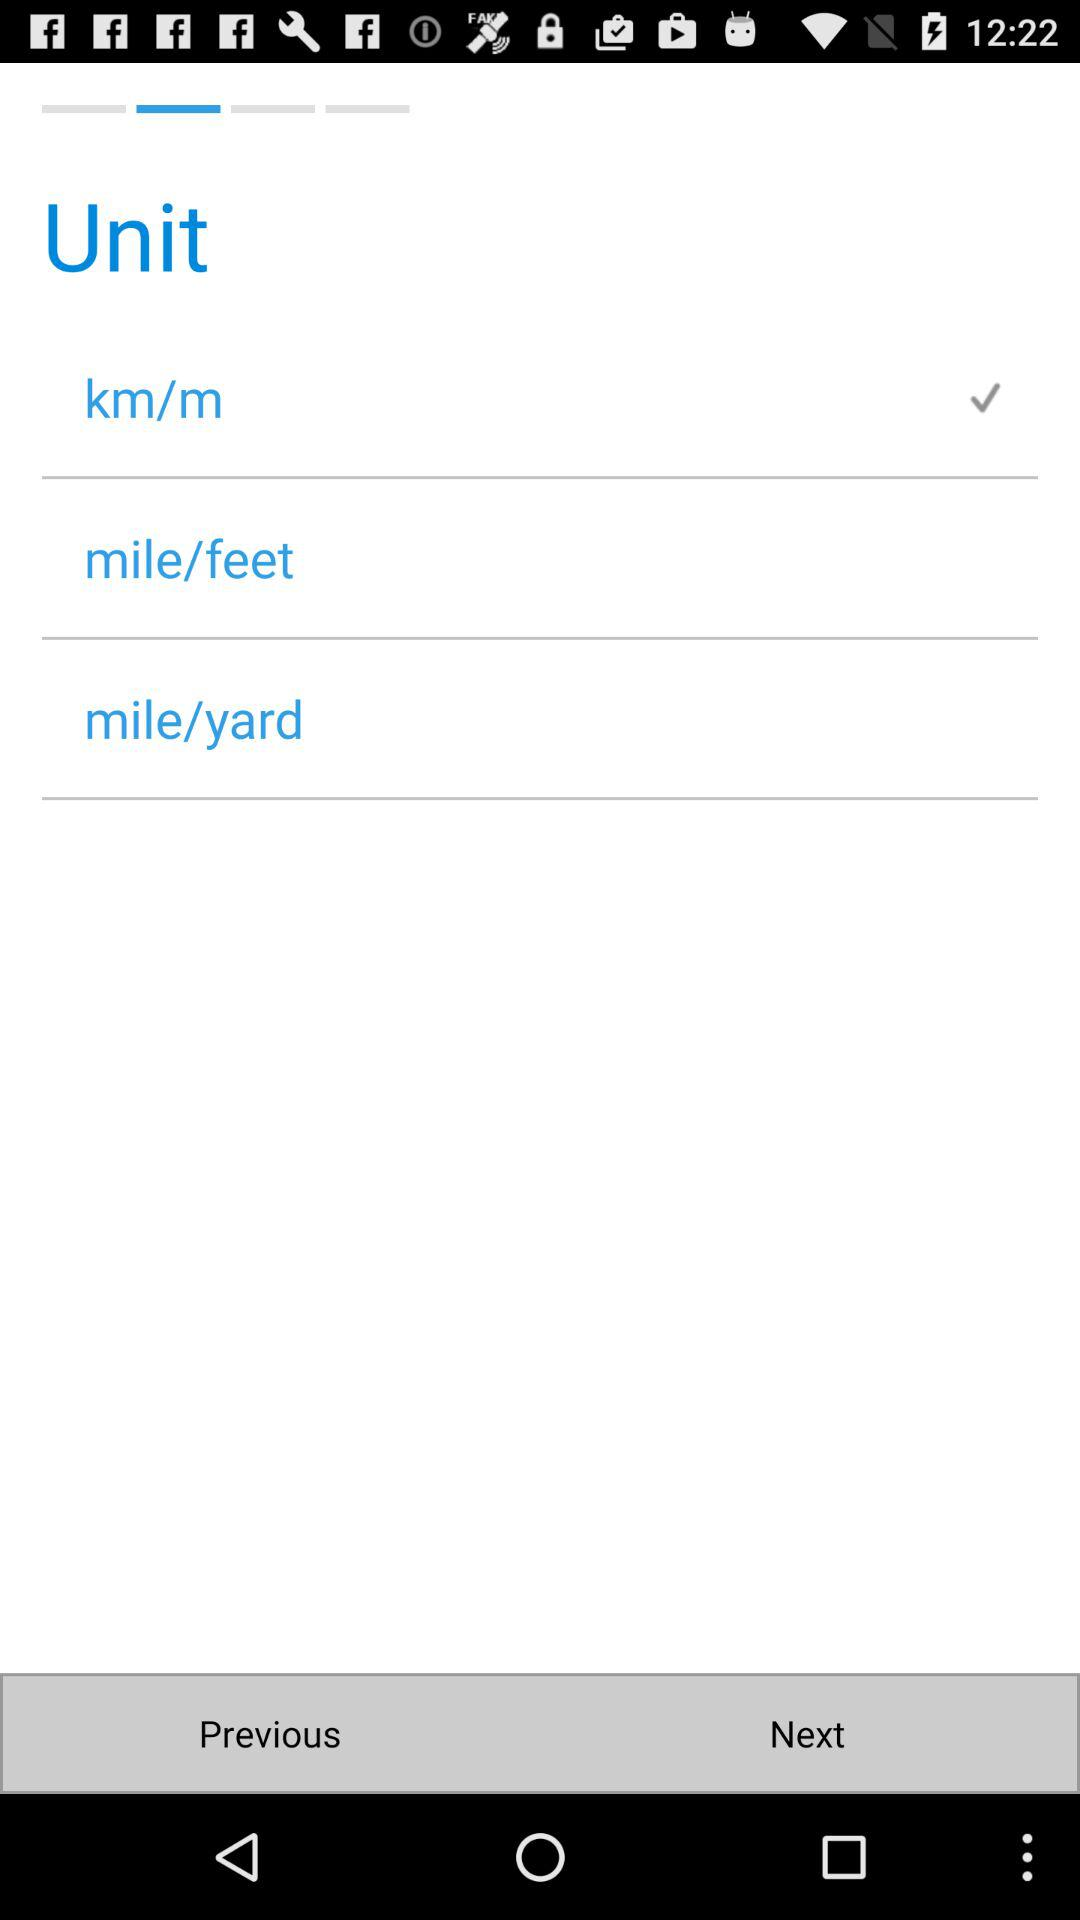Which unit is selected? The selected unit is km/m. 